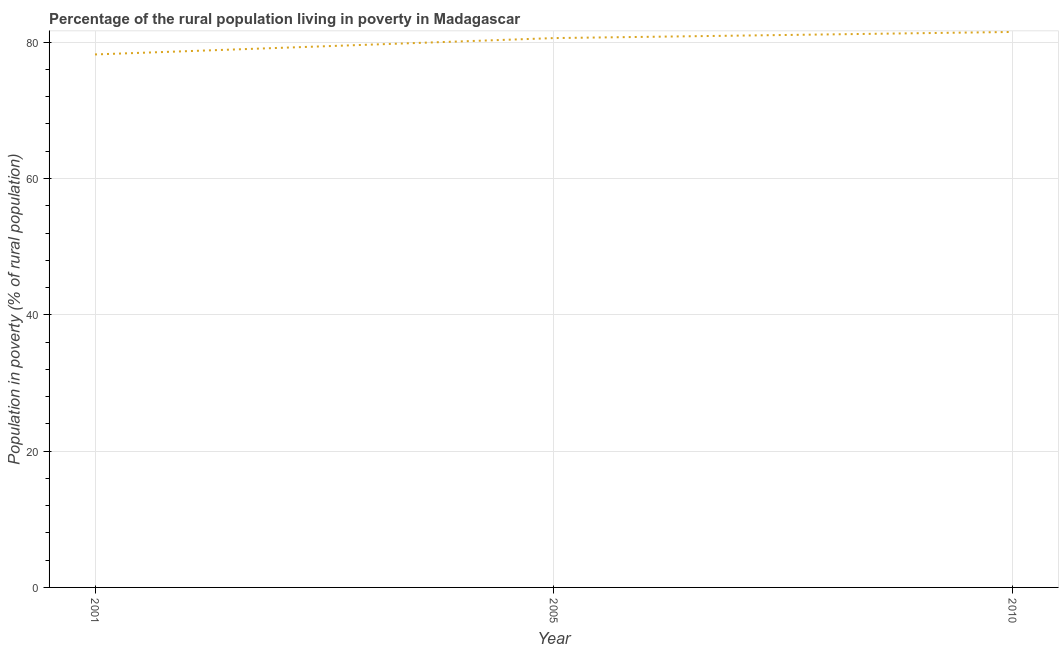What is the percentage of rural population living below poverty line in 2005?
Your response must be concise. 80.6. Across all years, what is the maximum percentage of rural population living below poverty line?
Offer a very short reply. 81.5. Across all years, what is the minimum percentage of rural population living below poverty line?
Offer a very short reply. 78.2. In which year was the percentage of rural population living below poverty line maximum?
Offer a terse response. 2010. What is the sum of the percentage of rural population living below poverty line?
Offer a terse response. 240.3. What is the difference between the percentage of rural population living below poverty line in 2001 and 2010?
Give a very brief answer. -3.3. What is the average percentage of rural population living below poverty line per year?
Provide a short and direct response. 80.1. What is the median percentage of rural population living below poverty line?
Offer a very short reply. 80.6. What is the ratio of the percentage of rural population living below poverty line in 2005 to that in 2010?
Offer a terse response. 0.99. Is the difference between the percentage of rural population living below poverty line in 2001 and 2005 greater than the difference between any two years?
Your response must be concise. No. What is the difference between the highest and the second highest percentage of rural population living below poverty line?
Offer a very short reply. 0.9. Is the sum of the percentage of rural population living below poverty line in 2001 and 2010 greater than the maximum percentage of rural population living below poverty line across all years?
Provide a succinct answer. Yes. What is the difference between the highest and the lowest percentage of rural population living below poverty line?
Your response must be concise. 3.3. How many lines are there?
Give a very brief answer. 1. What is the difference between two consecutive major ticks on the Y-axis?
Make the answer very short. 20. Are the values on the major ticks of Y-axis written in scientific E-notation?
Provide a succinct answer. No. Does the graph contain any zero values?
Keep it short and to the point. No. What is the title of the graph?
Your answer should be very brief. Percentage of the rural population living in poverty in Madagascar. What is the label or title of the X-axis?
Ensure brevity in your answer.  Year. What is the label or title of the Y-axis?
Your answer should be compact. Population in poverty (% of rural population). What is the Population in poverty (% of rural population) in 2001?
Provide a succinct answer. 78.2. What is the Population in poverty (% of rural population) in 2005?
Ensure brevity in your answer.  80.6. What is the Population in poverty (% of rural population) of 2010?
Provide a succinct answer. 81.5. What is the difference between the Population in poverty (% of rural population) in 2001 and 2005?
Make the answer very short. -2.4. What is the difference between the Population in poverty (% of rural population) in 2001 and 2010?
Your answer should be very brief. -3.3. What is the difference between the Population in poverty (% of rural population) in 2005 and 2010?
Keep it short and to the point. -0.9. What is the ratio of the Population in poverty (% of rural population) in 2001 to that in 2005?
Give a very brief answer. 0.97. 